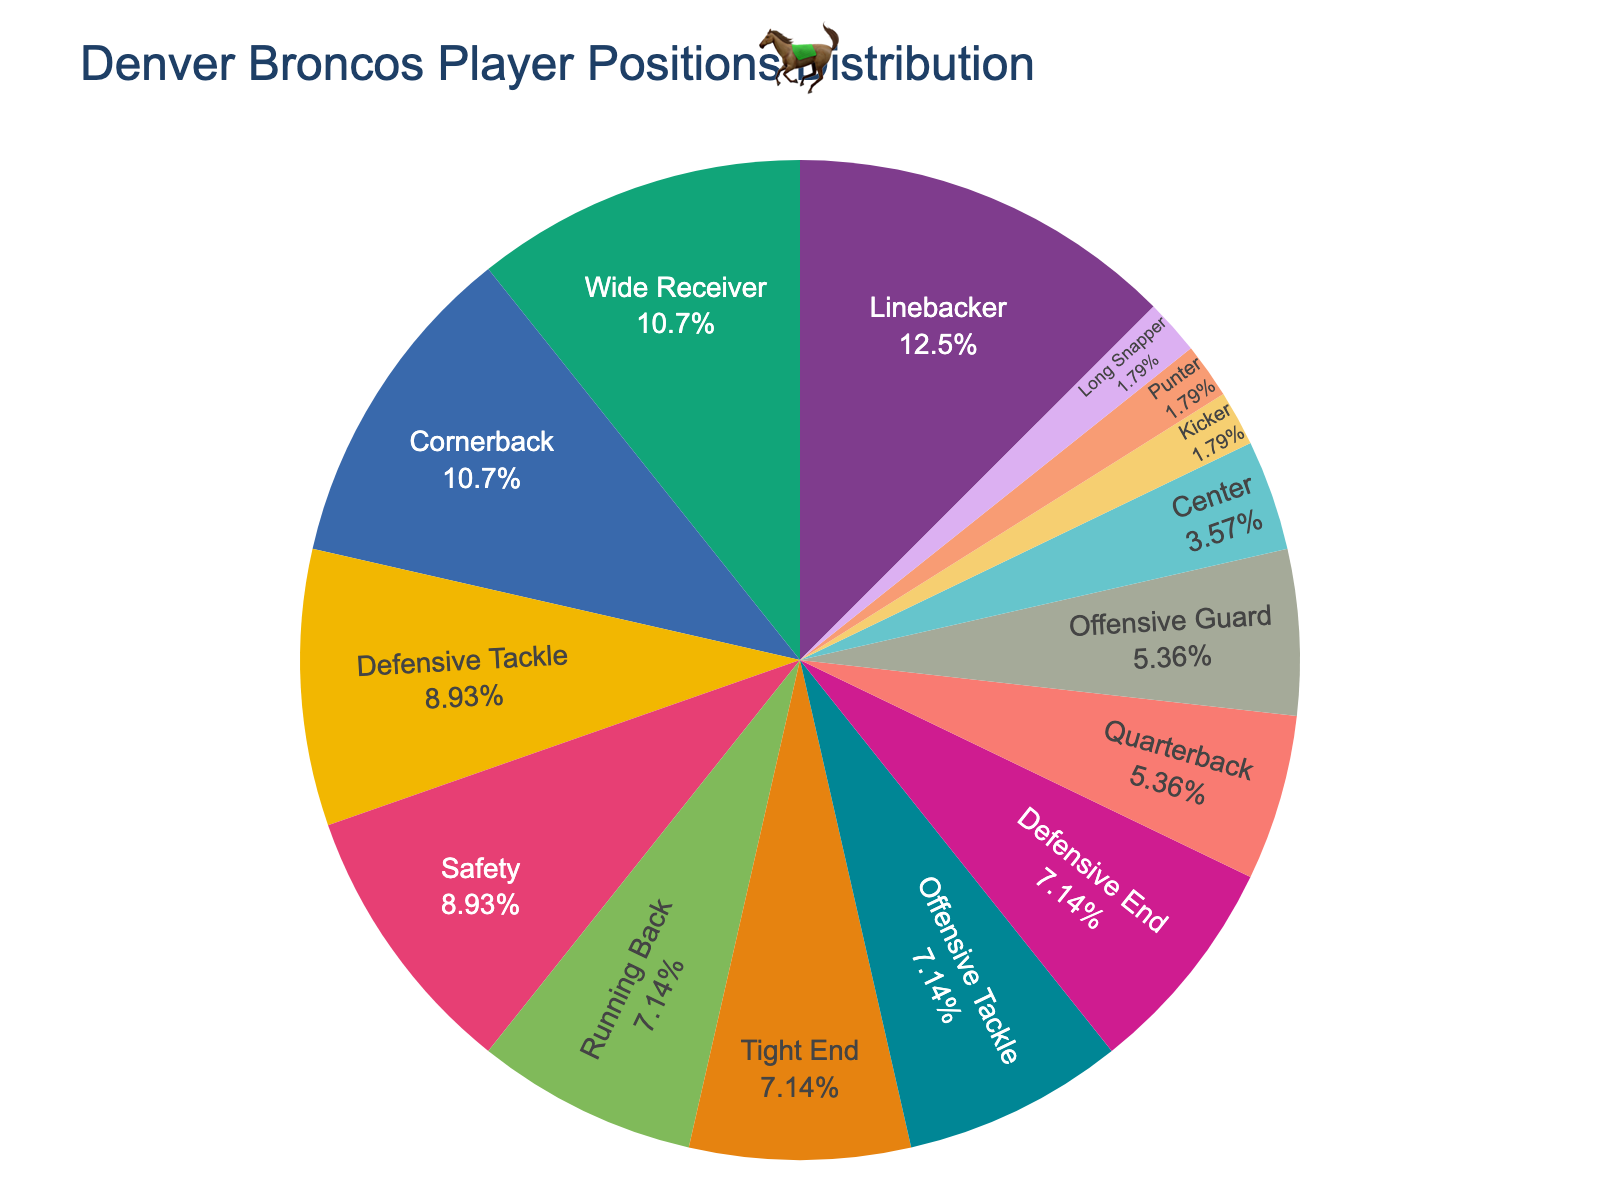Which position has the highest count of players? The pie chart shows the segmentation of player counts, and by visually inspecting the segments, we see that Linebacker has the largest segment.
Answer: Linebacker Which three positions combined contribute most to the roster? We need to find the sum of the highest three segments. Linebacker has 7, followed by Wide Receiver and Cornerback with 6 each. Summing these gives 7 + 6 + 6 = 19.
Answer: Linebacker, Wide Receiver, Cornerback How many more Linebackers are there compared to Quarterbacks? By looking at the counts, Linebacker has 7 players and Quarterback has 3. Subtracting these gives 7 - 3 = 4.
Answer: 4 Which position has exactly 4 players, and what percentage of the total roster does this represent? From the pie chart, we see that Running Back, Tight End, Offensive Tackle, and Defensive End each have 4 players. To find the percentage, we divide 4 by the total count (52), then multiply by 100, yielding approximately 7.7%.
Answer: Running Back, Tight End, Offensive Tackle, Defensive End; 7.7% Do any positions have the same number of players? If so, which ones? By checking the counts, we see both Running Back, Tight End, Offensive Tackle, and Defensive End have the same number of players, each having 4.
Answer: Running Back, Tight End, Offensive Tackle, Defensive End What is the total count of Offensive Line positions? The Offensive Line includes Offensive Tackle (4), Offensive Guard (3), and Center (2). Summing these, we get 4 + 3 + 2 = 9.
Answer: 9 Which position in the special teams has the least representation and how many players in total do special teams consist of? Special teams include Kicker (1), Punter (1), and Long Snapper (1), each having 1 player. Summing these yields 1 + 1 + 1 = 3. Therefore, Kicker, Punter, and Long Snapper each have the least representation with 1 player each.
Answer: Kicker, Punter, Long Snapper; 3 What is the percentage difference between the positions with the highest and lowest counts? Linebacker has the highest count with 7, and positions in special teams (Kicker, Punter, Long Snapper) have the lowest count with 1 each. The percentage difference is calculated as ((7 - 1) / 52) * 100 ≈ 11.5%.
Answer: 11.5% How does the combined count of Defensive End and Defensive Tackle compare to that of Wide Receiver and Cornerback? Defensive End has 4 players and Defensive Tackle has 5, totaling 4 + 5 = 9. Wide Receiver and Cornerback each have 6, totaling 6 + 6 = 12. Comparing these totals, 9 is less than 12.
Answer: Defensive positions have fewer players 